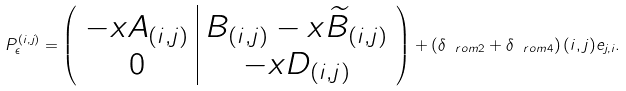<formula> <loc_0><loc_0><loc_500><loc_500>P _ { \epsilon } ^ { ( i , j ) } = \left ( \begin{array} { c | c } - x A _ { ( i , j ) } & B _ { ( i , j ) } - x \widetilde { B } _ { ( i , j ) } \\ 0 & - x D _ { ( i , j ) } \end{array} \right ) + \left ( \delta _ { \ r o m { 2 } } + \delta _ { \ r o m { 4 } } \right ) ( i , j ) e _ { j , i } .</formula> 